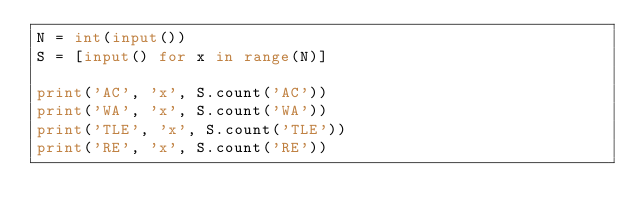Convert code to text. <code><loc_0><loc_0><loc_500><loc_500><_Python_>N = int(input())
S = [input() for x in range(N)]

print('AC', 'x', S.count('AC'))
print('WA', 'x', S.count('WA'))
print('TLE', 'x', S.count('TLE'))
print('RE', 'x', S.count('RE'))</code> 